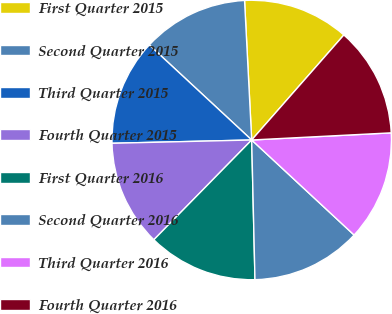<chart> <loc_0><loc_0><loc_500><loc_500><pie_chart><fcel>First Quarter 2015<fcel>Second Quarter 2015<fcel>Third Quarter 2015<fcel>Fourth Quarter 2015<fcel>First Quarter 2016<fcel>Second Quarter 2016<fcel>Third Quarter 2016<fcel>Fourth Quarter 2016<nl><fcel>12.28%<fcel>12.28%<fcel>12.28%<fcel>12.28%<fcel>12.72%<fcel>12.72%<fcel>12.72%<fcel>12.72%<nl></chart> 